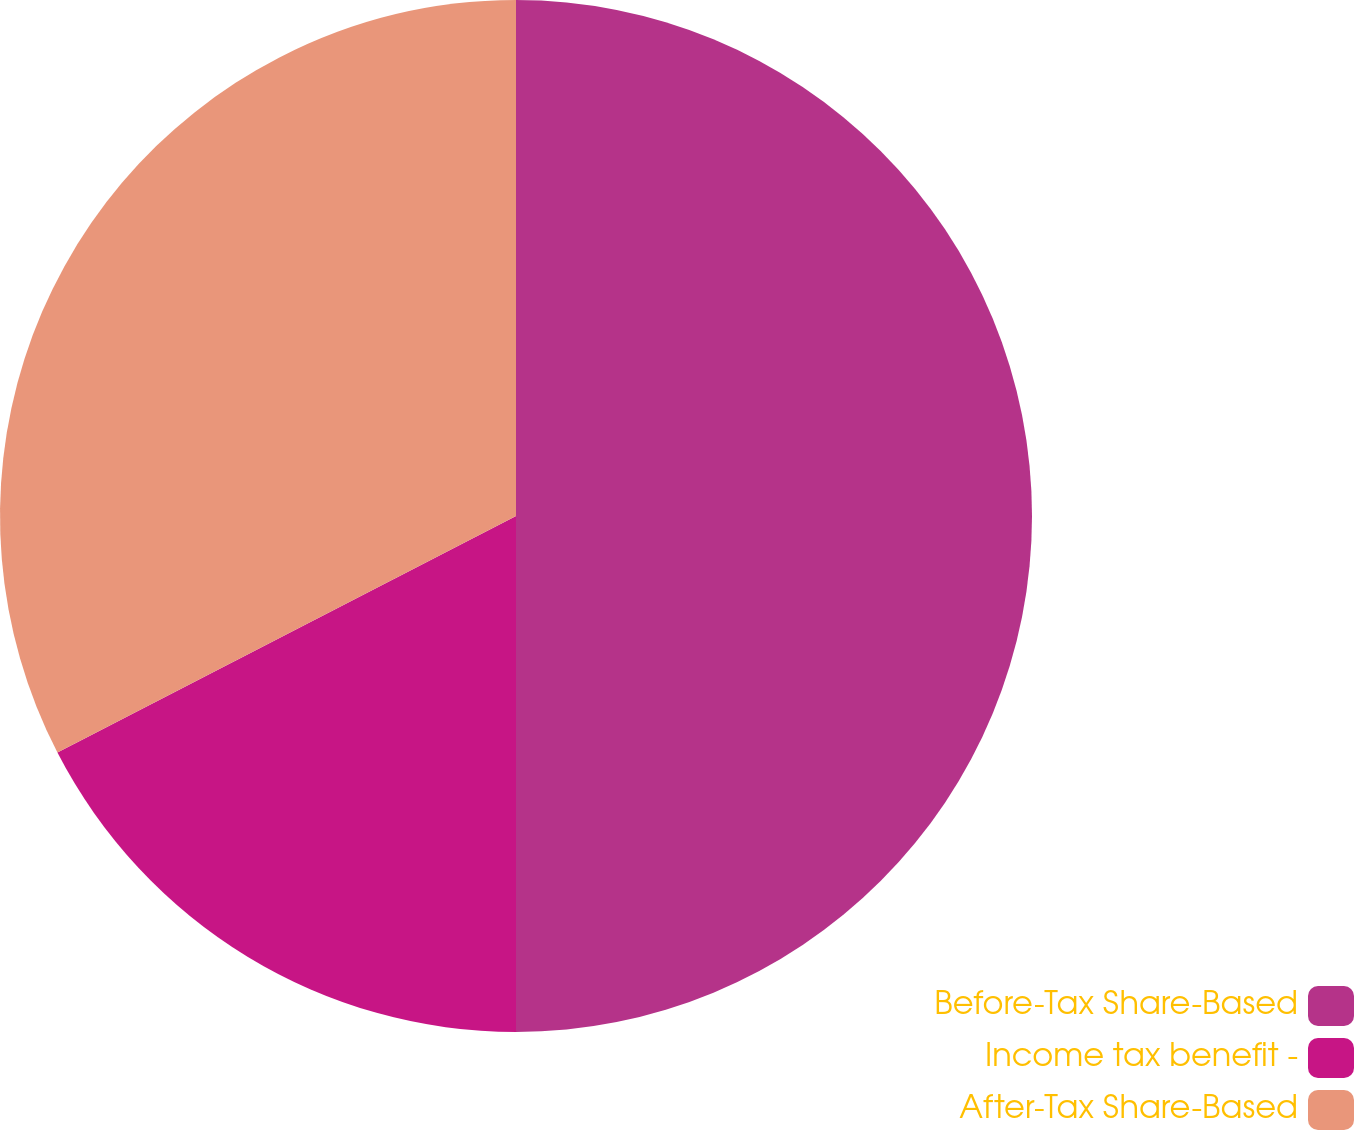Convert chart. <chart><loc_0><loc_0><loc_500><loc_500><pie_chart><fcel>Before-Tax Share-Based<fcel>Income tax benefit -<fcel>After-Tax Share-Based<nl><fcel>50.0%<fcel>17.42%<fcel>32.58%<nl></chart> 